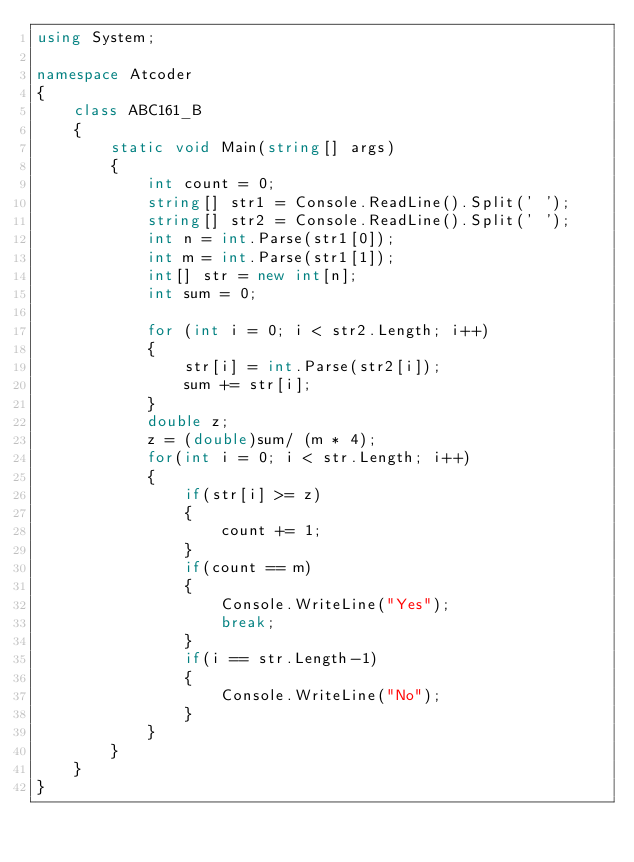Convert code to text. <code><loc_0><loc_0><loc_500><loc_500><_C#_>using System;

namespace Atcoder
{
    class ABC161_B
    {
        static void Main(string[] args)
        {
            int count = 0;
            string[] str1 = Console.ReadLine().Split(' ');
            string[] str2 = Console.ReadLine().Split(' ');
            int n = int.Parse(str1[0]);
            int m = int.Parse(str1[1]);
            int[] str = new int[n];
            int sum = 0;

            for (int i = 0; i < str2.Length; i++)
            {
                str[i] = int.Parse(str2[i]);
                sum += str[i];
            }
            double z;
            z = (double)sum/ (m * 4);
            for(int i = 0; i < str.Length; i++)
            {
                if(str[i] >= z)
                {
                    count += 1;
                }
                if(count == m)
                {
                    Console.WriteLine("Yes");
                    break;
                }
                if(i == str.Length-1)
                {
                    Console.WriteLine("No");
                }
            }
        }
    }
}
</code> 